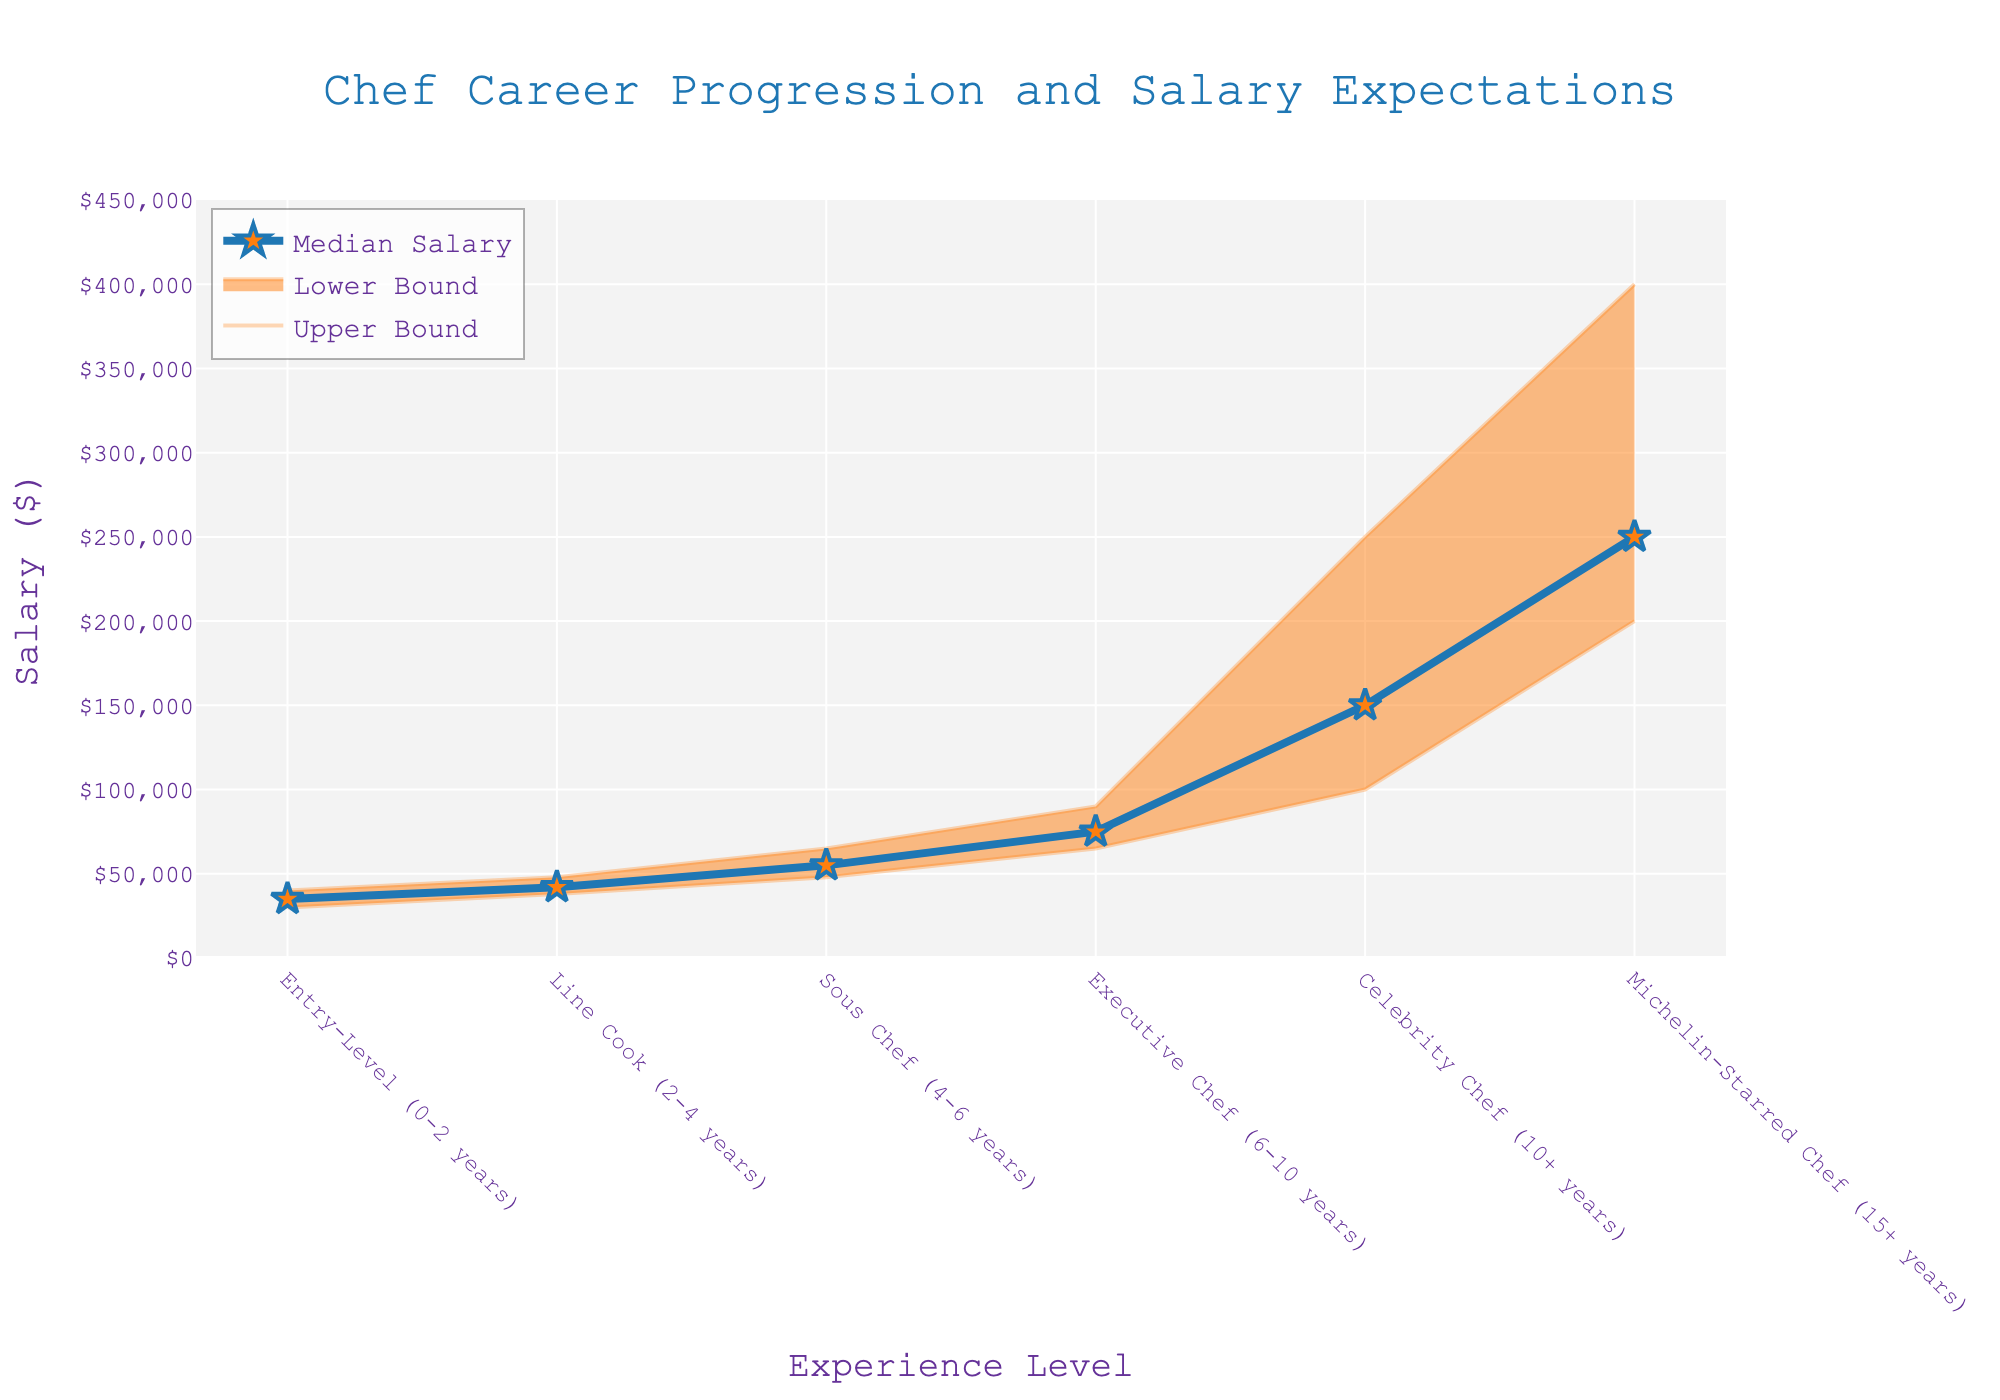What's the title of the figure? The title of the figure is displayed at the top center, explaining what the data represents.
Answer: Chef Career Progression and Salary Expectations What are the experience levels represented in the figure? The experience levels are listed on the x-axis of the figure. They are Entry-Level (0-2 years), Line Cook (2-4 years), Sous Chef (4-6 years), Executive Chef (6-10 years), Celebrity Chef (10+ years), and Michelin-Starred Chef (15+ years).
Answer: Entry-Level (0-2 years), Line Cook (2-4 years), Sous Chef (4-6 years), Executive Chef (6-10 years), Celebrity Chef (10+ years), Michelin-Starred Chef (15+ years) What is the median salary for a Michelin-Starred Chef (15+ years)? The median salary is represented by the star markers and the blue line. For Michelin-Starred Chefs, the marker associated with the experience level shows the median salary.
Answer: $250,000 What is the salary range for a Celebrity Chef (10+ years)? The salary range is demonstrated by the shaded area between the lower and upper bounds. For Celebrity Chefs, the lower bound is $100,000, and the upper bound is $250,000.
Answer: $100,000 - $250,000 What is the difference in median salary between a Line Cook (2-4 years) and a Sous Chef (4-6 years)? The difference can be found by subtracting the median salary of a Line Cook from that of a Sous Chef. The median salary for a Line Cook is $42,000, and for a Sous Chef, it is $55,000. The difference is $55,000 - $42,000.
Answer: $13,000 Which experience level has the widest salary range? By comparing the height of the shaded areas, the Michelin-Starred Chef (15+ years) has the widest range, from $200,000 to $400,000.
Answer: Michelin-Starred Chef (15+ years) How does the median salary trend as experience level increases? The median salary generally increases with experience level, illustrated by the upward trend of the blue line connecting the star markers.
Answer: Increases What is the salary upper bound for an Executive Chef (6-10 years)? The upper bound is represented by the top line of the shaded area for each experience level. For Executive Chefs, this is $90,000.
Answer: $90,000 